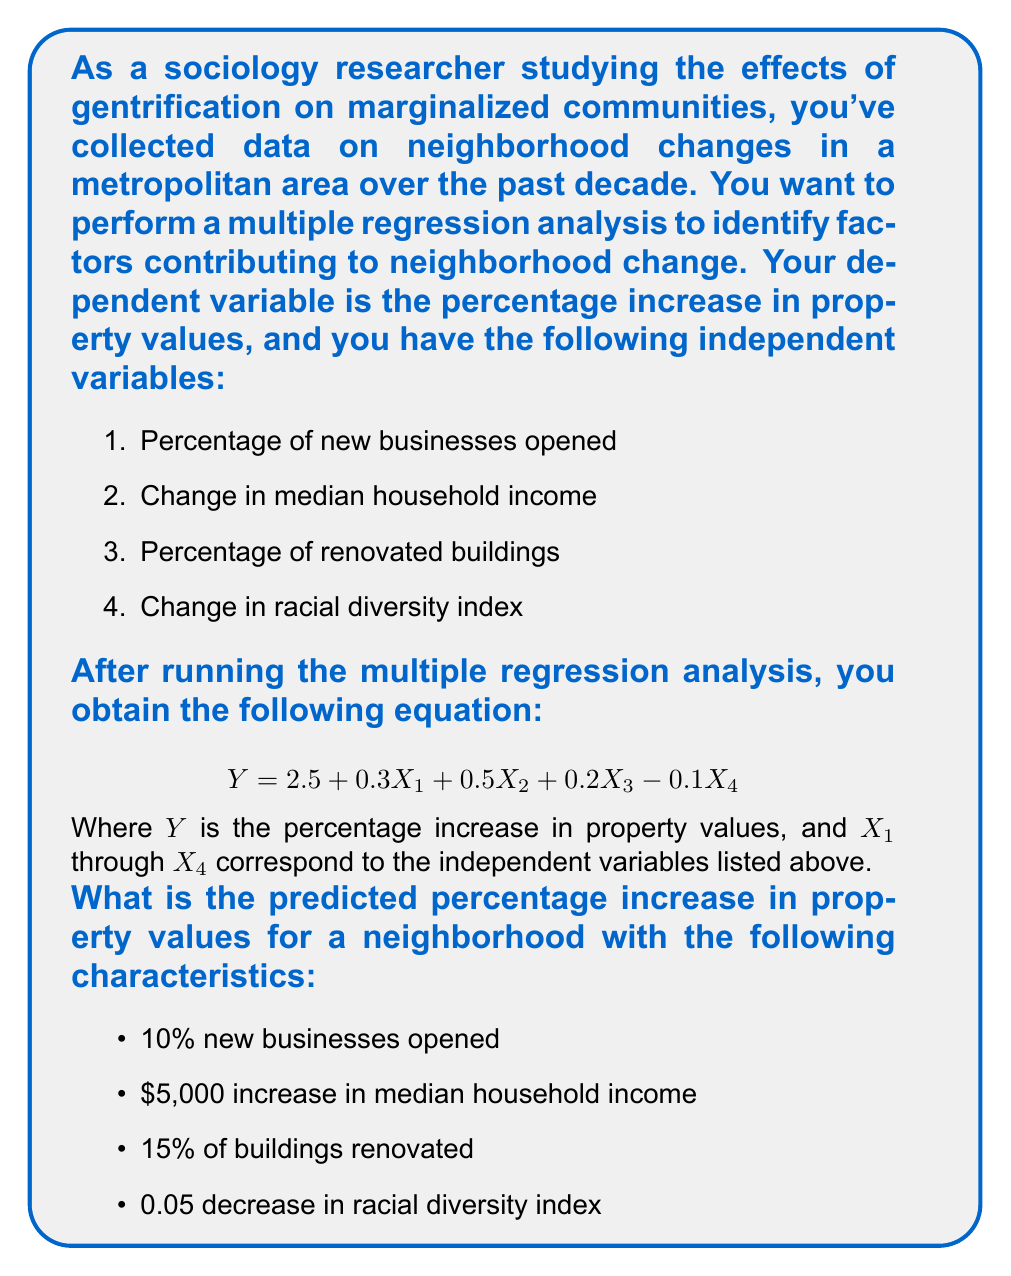Give your solution to this math problem. To solve this problem, we need to use the multiple regression equation provided and substitute the given values for each independent variable. Let's break it down step by step:

1. The regression equation is:
   $$ Y = 2.5 + 0.3X_1 + 0.5X_2 + 0.2X_3 - 0.1X_4 $$

2. We have the following values for each independent variable:
   - $X_1$ (Percentage of new businesses opened) = 10
   - $X_2$ (Change in median household income) = 5 (in thousands of dollars)
   - $X_3$ (Percentage of renovated buildings) = 15
   - $X_4$ (Change in racial diversity index) = -0.05

3. Let's substitute these values into the equation:
   $$ Y = 2.5 + 0.3(10) + 0.5(5) + 0.2(15) - 0.1(-0.05) $$

4. Now, let's calculate each term:
   - $2.5$ (constant term)
   - $0.3(10) = 3$
   - $0.5(5) = 2.5$
   - $0.2(15) = 3$
   - $-0.1(-0.05) = 0.005$

5. Sum up all the terms:
   $$ Y = 2.5 + 3 + 2.5 + 3 + 0.005 $$

6. Calculate the final result:
   $$ Y = 11.005 $$

Therefore, the predicted percentage increase in property values for the given neighborhood characteristics is 11.005%.
Answer: 11.005% 